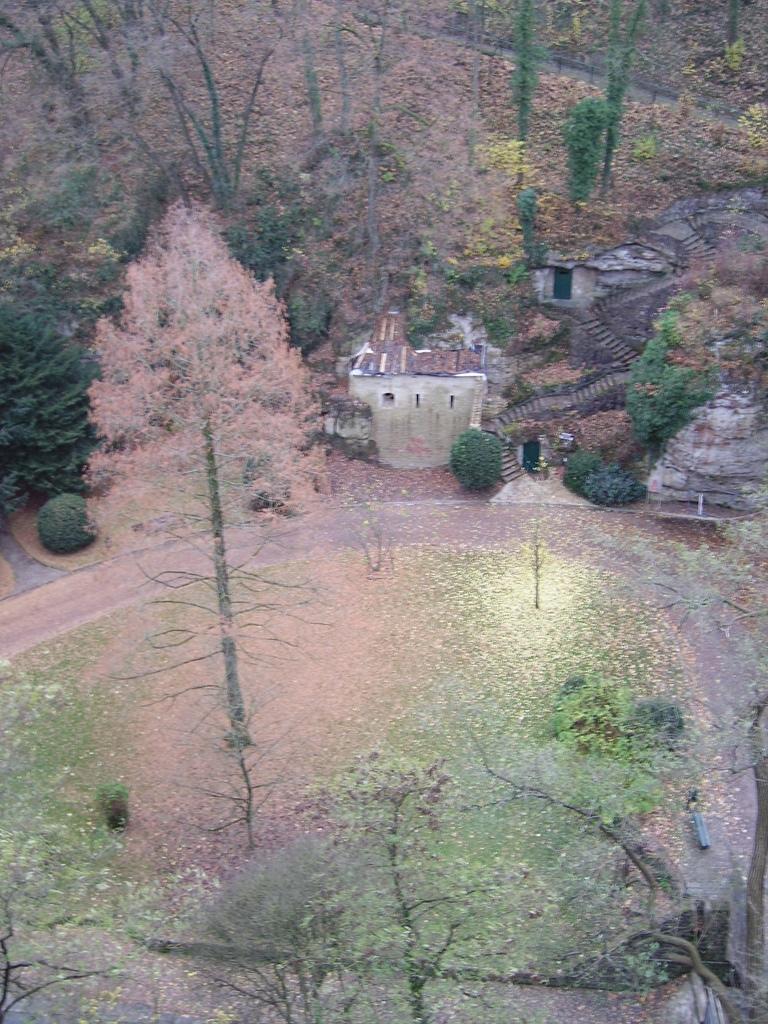How would you summarize this image in a sentence or two? In this image there are trees and there is a hut which is in the center and there are plants. 